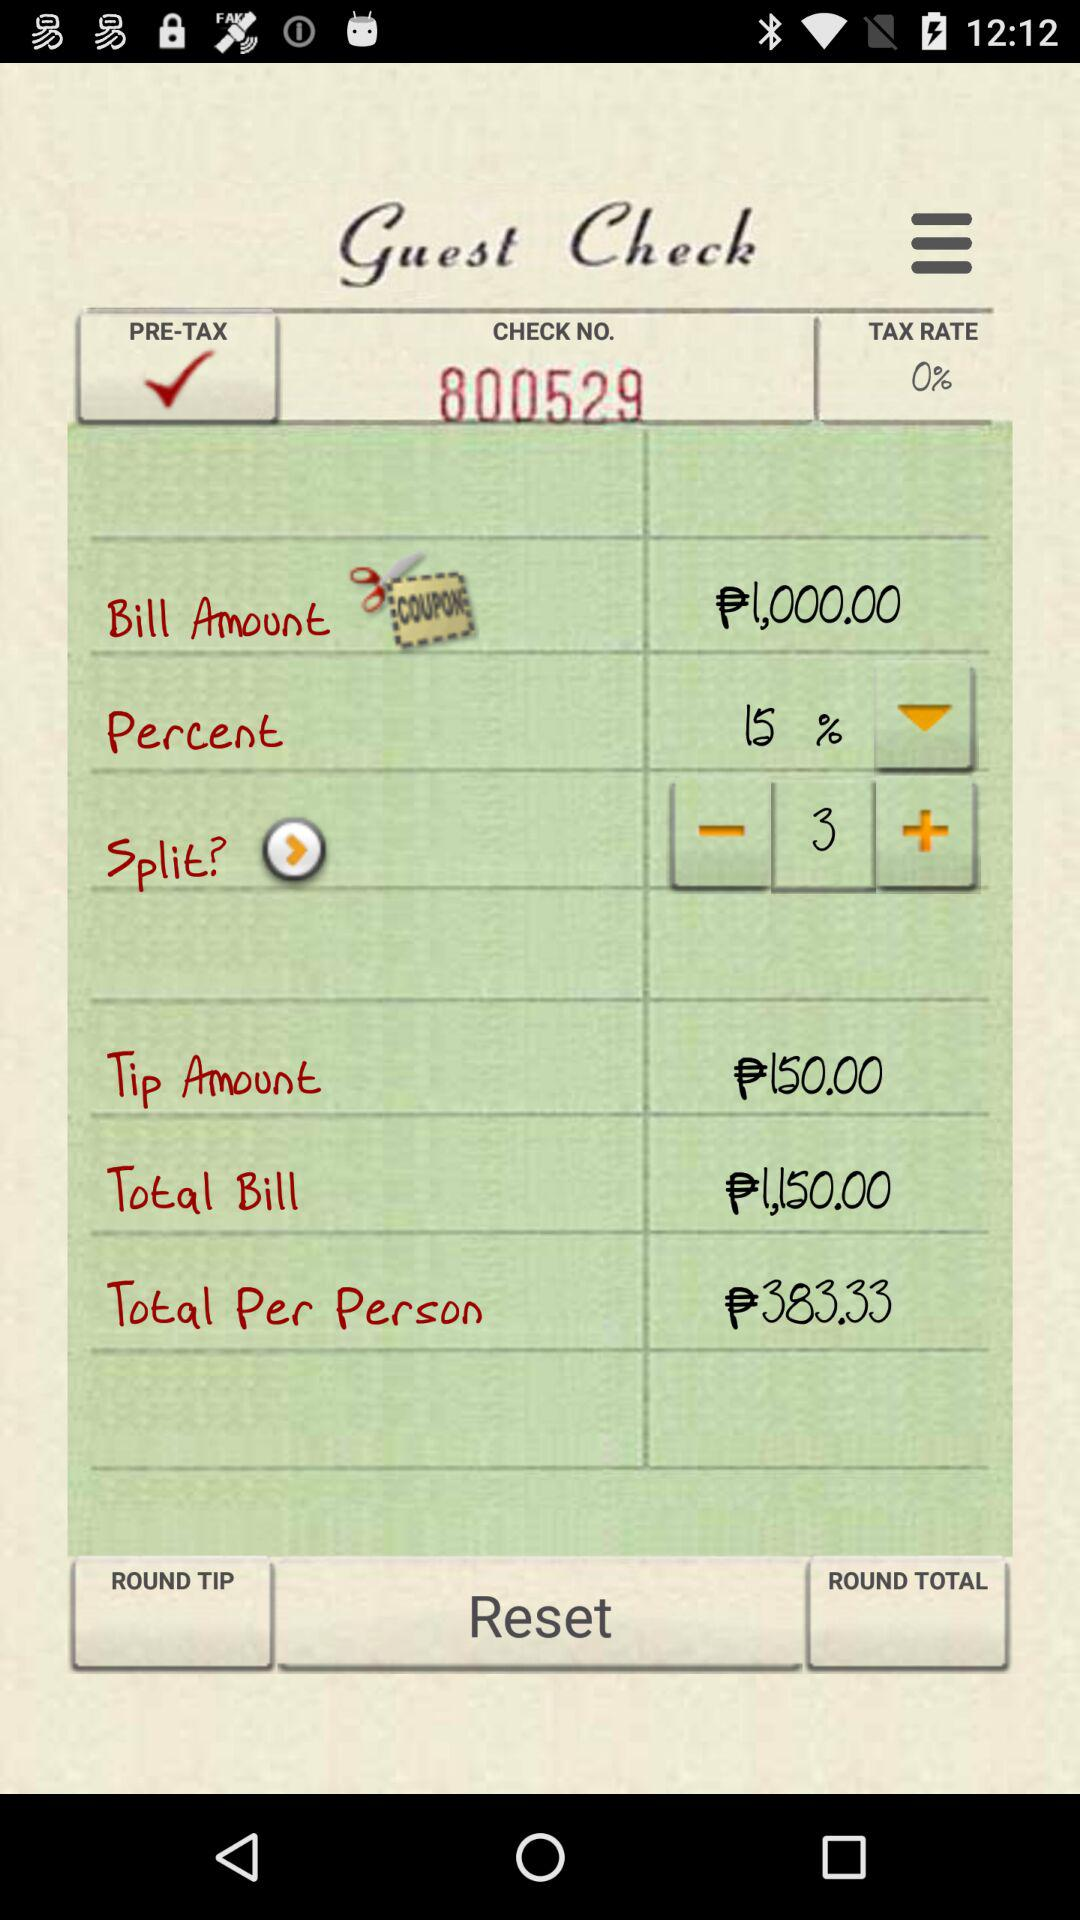What is the tax rate? The tax rate is 0%. 